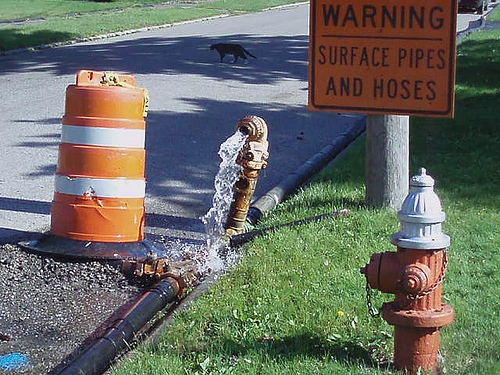Please transcribe the text information in this image. WARNING SURFACE PIPES AND HOSES 